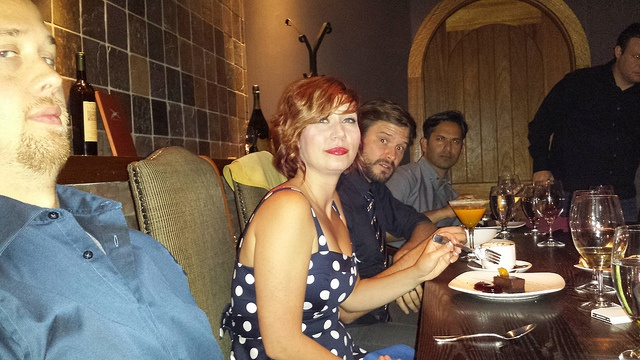Describe the objects in this image and their specific colors. I can see people in tan, gray, khaki, and lightblue tones, people in tan and gray tones, dining table in tan, maroon, black, ivory, and gray tones, people in tan, black, maroon, and brown tones, and chair in tan, olive, and gray tones in this image. 